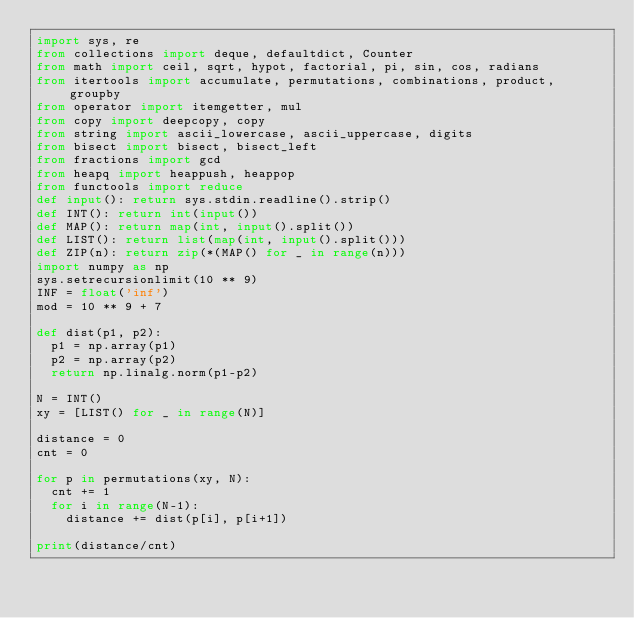Convert code to text. <code><loc_0><loc_0><loc_500><loc_500><_Python_>import sys, re
from collections import deque, defaultdict, Counter
from math import ceil, sqrt, hypot, factorial, pi, sin, cos, radians
from itertools import accumulate, permutations, combinations, product, groupby
from operator import itemgetter, mul
from copy import deepcopy, copy
from string import ascii_lowercase, ascii_uppercase, digits
from bisect import bisect, bisect_left
from fractions import gcd
from heapq import heappush, heappop
from functools import reduce
def input(): return sys.stdin.readline().strip()
def INT(): return int(input())
def MAP(): return map(int, input().split())
def LIST(): return list(map(int, input().split()))
def ZIP(n): return zip(*(MAP() for _ in range(n)))
import numpy as np
sys.setrecursionlimit(10 ** 9)
INF = float('inf')
mod = 10 ** 9 + 7

def dist(p1, p2):
	p1 = np.array(p1)
	p2 = np.array(p2)
	return np.linalg.norm(p1-p2)

N = INT()
xy = [LIST() for _ in range(N)]

distance = 0
cnt = 0

for p in permutations(xy, N):
	cnt += 1
	for i in range(N-1):
		distance += dist(p[i], p[i+1])

print(distance/cnt)</code> 